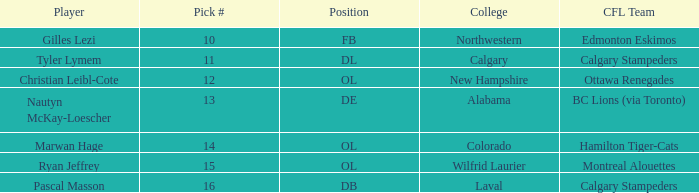Which player from the 2004 CFL draft attended Wilfrid Laurier? Ryan Jeffrey. 